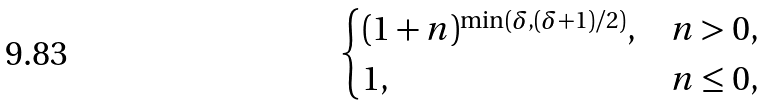Convert formula to latex. <formula><loc_0><loc_0><loc_500><loc_500>\begin{cases} ( 1 + n ) ^ { \min ( \delta , ( \delta + 1 ) / 2 ) } , & n > 0 , \\ 1 , & n \leq 0 , \end{cases}</formula> 